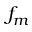<formula> <loc_0><loc_0><loc_500><loc_500>f _ { m }</formula> 